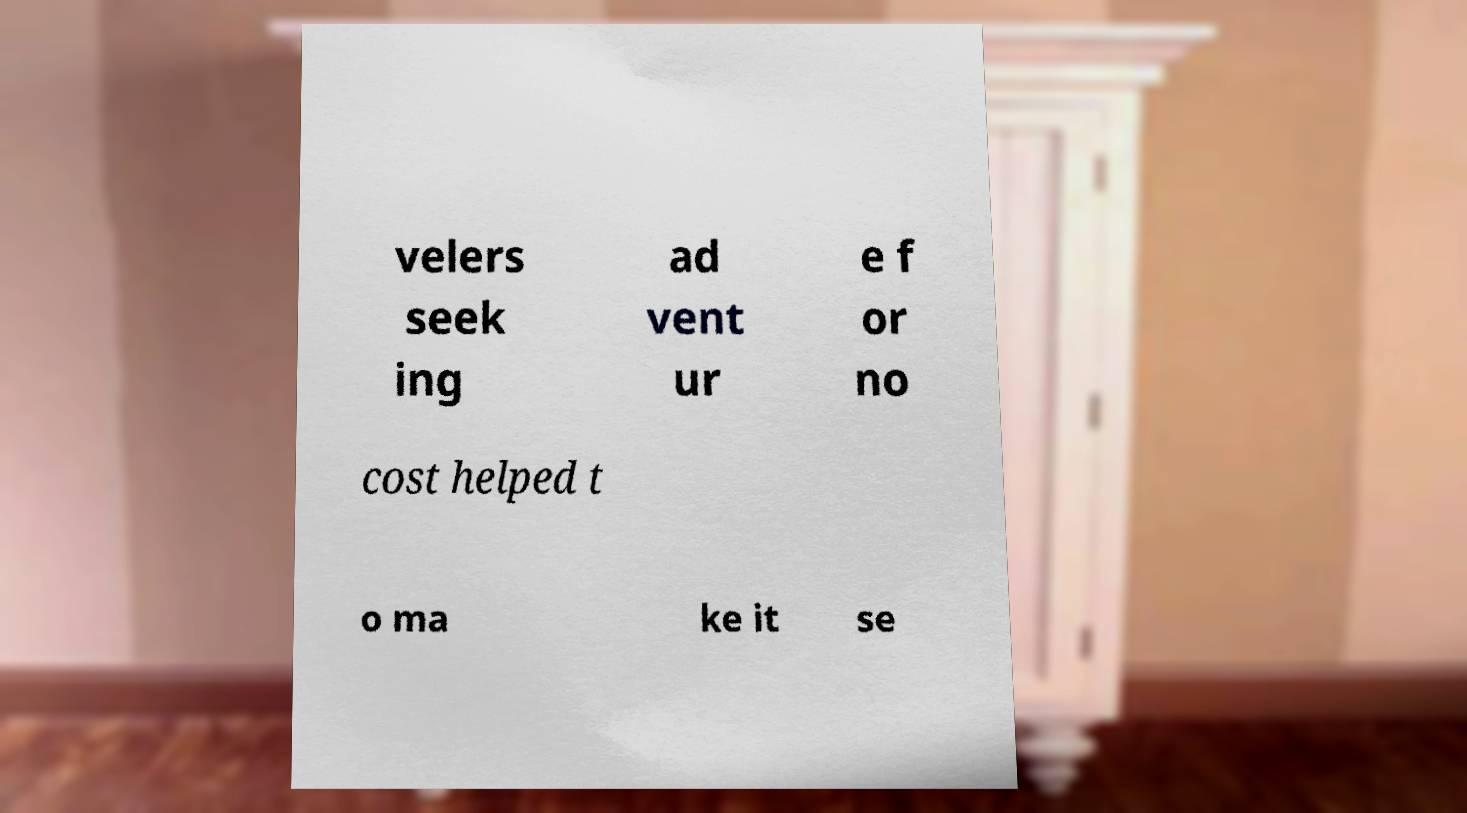Can you read and provide the text displayed in the image?This photo seems to have some interesting text. Can you extract and type it out for me? velers seek ing ad vent ur e f or no cost helped t o ma ke it se 